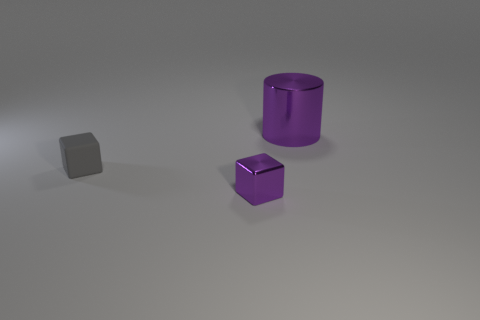Add 1 tiny green rubber cylinders. How many objects exist? 4 Subtract all cylinders. How many objects are left? 2 Subtract 0 yellow spheres. How many objects are left? 3 Subtract all red cylinders. Subtract all red cubes. How many cylinders are left? 1 Subtract all tiny yellow rubber cylinders. Subtract all gray matte objects. How many objects are left? 2 Add 1 large purple metallic things. How many large purple metallic things are left? 2 Add 2 cyan spheres. How many cyan spheres exist? 2 